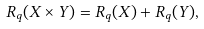<formula> <loc_0><loc_0><loc_500><loc_500>R _ { q } ( X \times Y ) = R _ { q } ( X ) + R _ { q } ( Y ) ,</formula> 